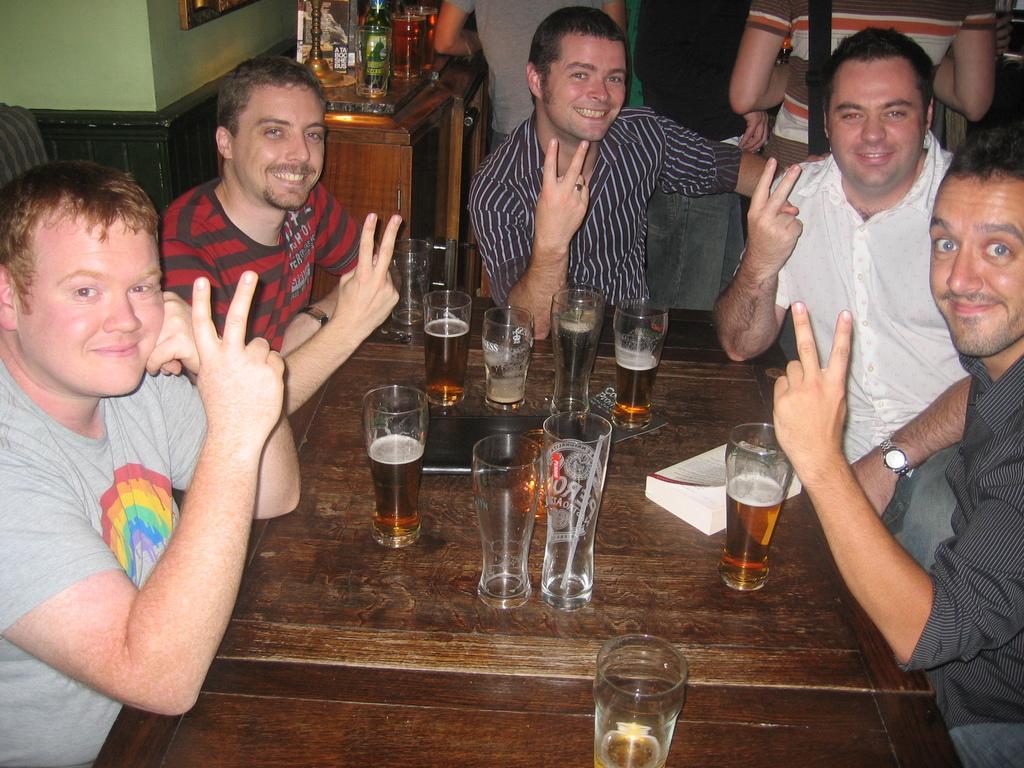Can you describe this image briefly? This 4 people are sitting on a chair. In-front of them there is a table, on a table there are glasses. Backside of this person's few people are standing. Beside this person there is a table, on a table there is a bottle. Wall is in green color. 